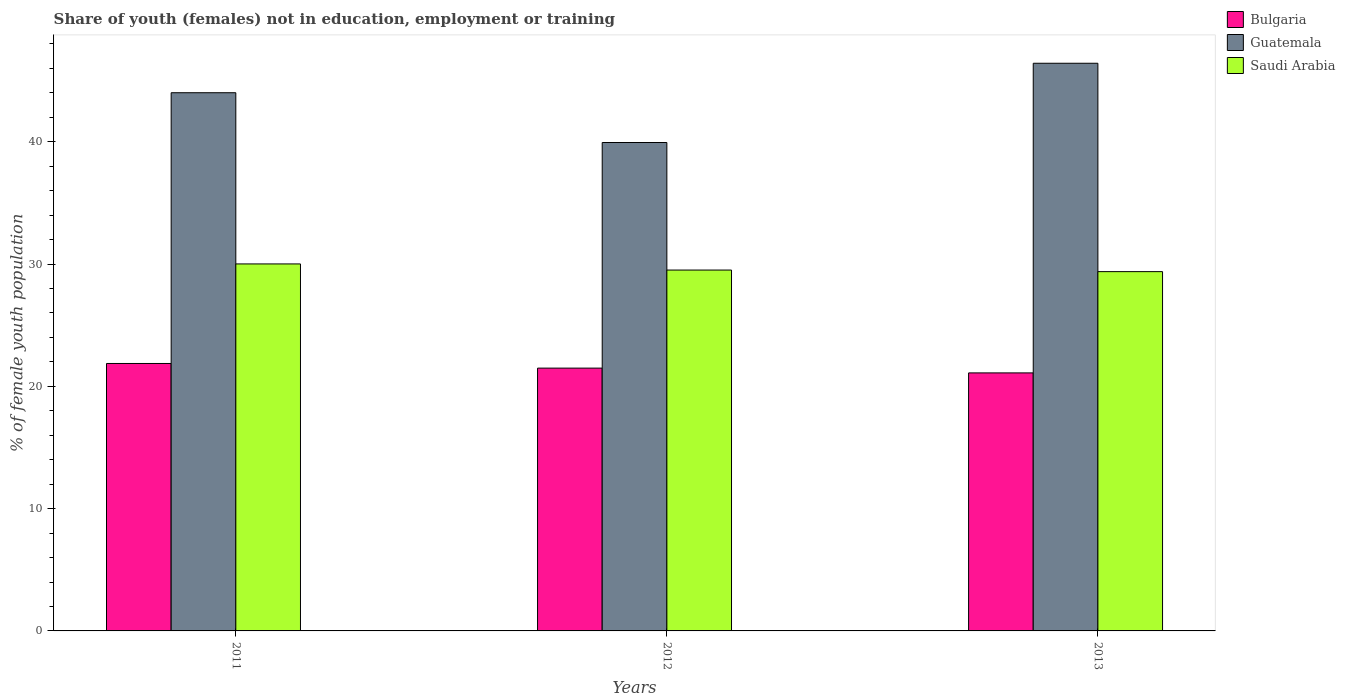How many groups of bars are there?
Your response must be concise. 3. Are the number of bars per tick equal to the number of legend labels?
Provide a short and direct response. Yes. How many bars are there on the 3rd tick from the left?
Your answer should be very brief. 3. What is the label of the 1st group of bars from the left?
Give a very brief answer. 2011. In how many cases, is the number of bars for a given year not equal to the number of legend labels?
Your response must be concise. 0. What is the percentage of unemployed female population in in Bulgaria in 2011?
Give a very brief answer. 21.87. Across all years, what is the maximum percentage of unemployed female population in in Saudi Arabia?
Give a very brief answer. 30.01. Across all years, what is the minimum percentage of unemployed female population in in Guatemala?
Your answer should be very brief. 39.94. In which year was the percentage of unemployed female population in in Bulgaria maximum?
Your response must be concise. 2011. In which year was the percentage of unemployed female population in in Bulgaria minimum?
Give a very brief answer. 2013. What is the total percentage of unemployed female population in in Guatemala in the graph?
Give a very brief answer. 130.37. What is the difference between the percentage of unemployed female population in in Saudi Arabia in 2012 and that in 2013?
Offer a very short reply. 0.13. What is the difference between the percentage of unemployed female population in in Saudi Arabia in 2011 and the percentage of unemployed female population in in Guatemala in 2013?
Your response must be concise. -16.41. What is the average percentage of unemployed female population in in Guatemala per year?
Offer a very short reply. 43.46. In the year 2011, what is the difference between the percentage of unemployed female population in in Saudi Arabia and percentage of unemployed female population in in Guatemala?
Make the answer very short. -14. What is the ratio of the percentage of unemployed female population in in Guatemala in 2011 to that in 2013?
Give a very brief answer. 0.95. Is the difference between the percentage of unemployed female population in in Saudi Arabia in 2011 and 2013 greater than the difference between the percentage of unemployed female population in in Guatemala in 2011 and 2013?
Your response must be concise. Yes. What is the difference between the highest and the second highest percentage of unemployed female population in in Bulgaria?
Offer a very short reply. 0.38. What is the difference between the highest and the lowest percentage of unemployed female population in in Bulgaria?
Give a very brief answer. 0.77. In how many years, is the percentage of unemployed female population in in Bulgaria greater than the average percentage of unemployed female population in in Bulgaria taken over all years?
Keep it short and to the point. 2. What does the 1st bar from the left in 2013 represents?
Your answer should be compact. Bulgaria. What does the 3rd bar from the right in 2011 represents?
Provide a succinct answer. Bulgaria. Is it the case that in every year, the sum of the percentage of unemployed female population in in Guatemala and percentage of unemployed female population in in Saudi Arabia is greater than the percentage of unemployed female population in in Bulgaria?
Keep it short and to the point. Yes. Are all the bars in the graph horizontal?
Your response must be concise. No. How many years are there in the graph?
Give a very brief answer. 3. Are the values on the major ticks of Y-axis written in scientific E-notation?
Your answer should be compact. No. Does the graph contain any zero values?
Keep it short and to the point. No. Does the graph contain grids?
Your response must be concise. No. How many legend labels are there?
Keep it short and to the point. 3. What is the title of the graph?
Your answer should be compact. Share of youth (females) not in education, employment or training. Does "Egypt, Arab Rep." appear as one of the legend labels in the graph?
Keep it short and to the point. No. What is the label or title of the Y-axis?
Your answer should be very brief. % of female youth population. What is the % of female youth population in Bulgaria in 2011?
Offer a very short reply. 21.87. What is the % of female youth population in Guatemala in 2011?
Ensure brevity in your answer.  44.01. What is the % of female youth population in Saudi Arabia in 2011?
Give a very brief answer. 30.01. What is the % of female youth population in Bulgaria in 2012?
Your answer should be very brief. 21.49. What is the % of female youth population in Guatemala in 2012?
Keep it short and to the point. 39.94. What is the % of female youth population in Saudi Arabia in 2012?
Your answer should be very brief. 29.51. What is the % of female youth population of Bulgaria in 2013?
Offer a very short reply. 21.1. What is the % of female youth population of Guatemala in 2013?
Keep it short and to the point. 46.42. What is the % of female youth population of Saudi Arabia in 2013?
Offer a terse response. 29.38. Across all years, what is the maximum % of female youth population of Bulgaria?
Your answer should be compact. 21.87. Across all years, what is the maximum % of female youth population of Guatemala?
Offer a terse response. 46.42. Across all years, what is the maximum % of female youth population in Saudi Arabia?
Provide a short and direct response. 30.01. Across all years, what is the minimum % of female youth population of Bulgaria?
Your response must be concise. 21.1. Across all years, what is the minimum % of female youth population in Guatemala?
Your response must be concise. 39.94. Across all years, what is the minimum % of female youth population in Saudi Arabia?
Provide a short and direct response. 29.38. What is the total % of female youth population of Bulgaria in the graph?
Provide a short and direct response. 64.46. What is the total % of female youth population in Guatemala in the graph?
Offer a terse response. 130.37. What is the total % of female youth population of Saudi Arabia in the graph?
Offer a very short reply. 88.9. What is the difference between the % of female youth population in Bulgaria in 2011 and that in 2012?
Your answer should be compact. 0.38. What is the difference between the % of female youth population in Guatemala in 2011 and that in 2012?
Keep it short and to the point. 4.07. What is the difference between the % of female youth population in Bulgaria in 2011 and that in 2013?
Ensure brevity in your answer.  0.77. What is the difference between the % of female youth population of Guatemala in 2011 and that in 2013?
Your response must be concise. -2.41. What is the difference between the % of female youth population in Saudi Arabia in 2011 and that in 2013?
Offer a terse response. 0.63. What is the difference between the % of female youth population in Bulgaria in 2012 and that in 2013?
Provide a short and direct response. 0.39. What is the difference between the % of female youth population of Guatemala in 2012 and that in 2013?
Your answer should be very brief. -6.48. What is the difference between the % of female youth population in Saudi Arabia in 2012 and that in 2013?
Your answer should be compact. 0.13. What is the difference between the % of female youth population in Bulgaria in 2011 and the % of female youth population in Guatemala in 2012?
Offer a very short reply. -18.07. What is the difference between the % of female youth population of Bulgaria in 2011 and the % of female youth population of Saudi Arabia in 2012?
Your response must be concise. -7.64. What is the difference between the % of female youth population in Guatemala in 2011 and the % of female youth population in Saudi Arabia in 2012?
Your answer should be very brief. 14.5. What is the difference between the % of female youth population of Bulgaria in 2011 and the % of female youth population of Guatemala in 2013?
Keep it short and to the point. -24.55. What is the difference between the % of female youth population in Bulgaria in 2011 and the % of female youth population in Saudi Arabia in 2013?
Keep it short and to the point. -7.51. What is the difference between the % of female youth population of Guatemala in 2011 and the % of female youth population of Saudi Arabia in 2013?
Provide a short and direct response. 14.63. What is the difference between the % of female youth population of Bulgaria in 2012 and the % of female youth population of Guatemala in 2013?
Offer a very short reply. -24.93. What is the difference between the % of female youth population in Bulgaria in 2012 and the % of female youth population in Saudi Arabia in 2013?
Give a very brief answer. -7.89. What is the difference between the % of female youth population of Guatemala in 2012 and the % of female youth population of Saudi Arabia in 2013?
Provide a succinct answer. 10.56. What is the average % of female youth population in Bulgaria per year?
Your answer should be very brief. 21.49. What is the average % of female youth population in Guatemala per year?
Keep it short and to the point. 43.46. What is the average % of female youth population of Saudi Arabia per year?
Your answer should be compact. 29.63. In the year 2011, what is the difference between the % of female youth population of Bulgaria and % of female youth population of Guatemala?
Make the answer very short. -22.14. In the year 2011, what is the difference between the % of female youth population of Bulgaria and % of female youth population of Saudi Arabia?
Make the answer very short. -8.14. In the year 2011, what is the difference between the % of female youth population of Guatemala and % of female youth population of Saudi Arabia?
Your answer should be compact. 14. In the year 2012, what is the difference between the % of female youth population in Bulgaria and % of female youth population in Guatemala?
Ensure brevity in your answer.  -18.45. In the year 2012, what is the difference between the % of female youth population in Bulgaria and % of female youth population in Saudi Arabia?
Ensure brevity in your answer.  -8.02. In the year 2012, what is the difference between the % of female youth population in Guatemala and % of female youth population in Saudi Arabia?
Offer a terse response. 10.43. In the year 2013, what is the difference between the % of female youth population of Bulgaria and % of female youth population of Guatemala?
Provide a succinct answer. -25.32. In the year 2013, what is the difference between the % of female youth population of Bulgaria and % of female youth population of Saudi Arabia?
Offer a very short reply. -8.28. In the year 2013, what is the difference between the % of female youth population of Guatemala and % of female youth population of Saudi Arabia?
Your answer should be very brief. 17.04. What is the ratio of the % of female youth population of Bulgaria in 2011 to that in 2012?
Provide a succinct answer. 1.02. What is the ratio of the % of female youth population of Guatemala in 2011 to that in 2012?
Offer a terse response. 1.1. What is the ratio of the % of female youth population in Saudi Arabia in 2011 to that in 2012?
Your answer should be compact. 1.02. What is the ratio of the % of female youth population of Bulgaria in 2011 to that in 2013?
Your response must be concise. 1.04. What is the ratio of the % of female youth population of Guatemala in 2011 to that in 2013?
Keep it short and to the point. 0.95. What is the ratio of the % of female youth population in Saudi Arabia in 2011 to that in 2013?
Ensure brevity in your answer.  1.02. What is the ratio of the % of female youth population of Bulgaria in 2012 to that in 2013?
Provide a short and direct response. 1.02. What is the ratio of the % of female youth population of Guatemala in 2012 to that in 2013?
Make the answer very short. 0.86. What is the ratio of the % of female youth population in Saudi Arabia in 2012 to that in 2013?
Keep it short and to the point. 1. What is the difference between the highest and the second highest % of female youth population of Bulgaria?
Offer a very short reply. 0.38. What is the difference between the highest and the second highest % of female youth population in Guatemala?
Your answer should be very brief. 2.41. What is the difference between the highest and the lowest % of female youth population in Bulgaria?
Keep it short and to the point. 0.77. What is the difference between the highest and the lowest % of female youth population in Guatemala?
Your answer should be compact. 6.48. What is the difference between the highest and the lowest % of female youth population of Saudi Arabia?
Offer a very short reply. 0.63. 